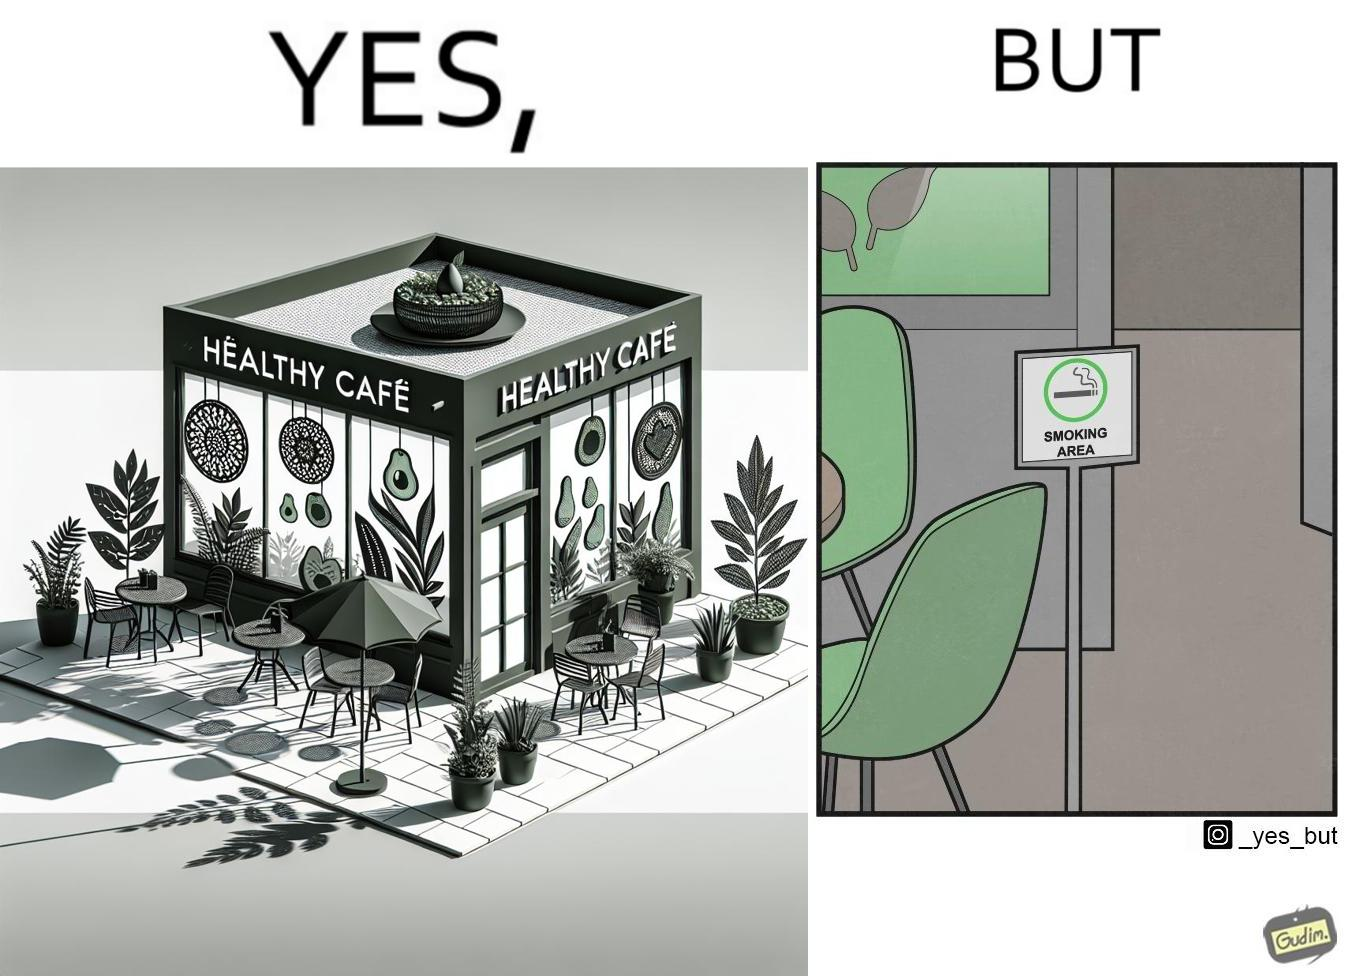Describe the satirical element in this image. This image is funny because an eatery that calls itself the "healthy" cafe also has a smoking area, which is not very "healthy". If it really was a healthy cafe, it would not have a smoking area as smoking is injurious to health. Satire on the behavior of humans - both those that operate this cafe who made the decision of allowing smoking and creating a designated smoking area, and those that visit this healthy cafe to become "healthy", but then also indulge in very unhealthy habits simultaneously. 